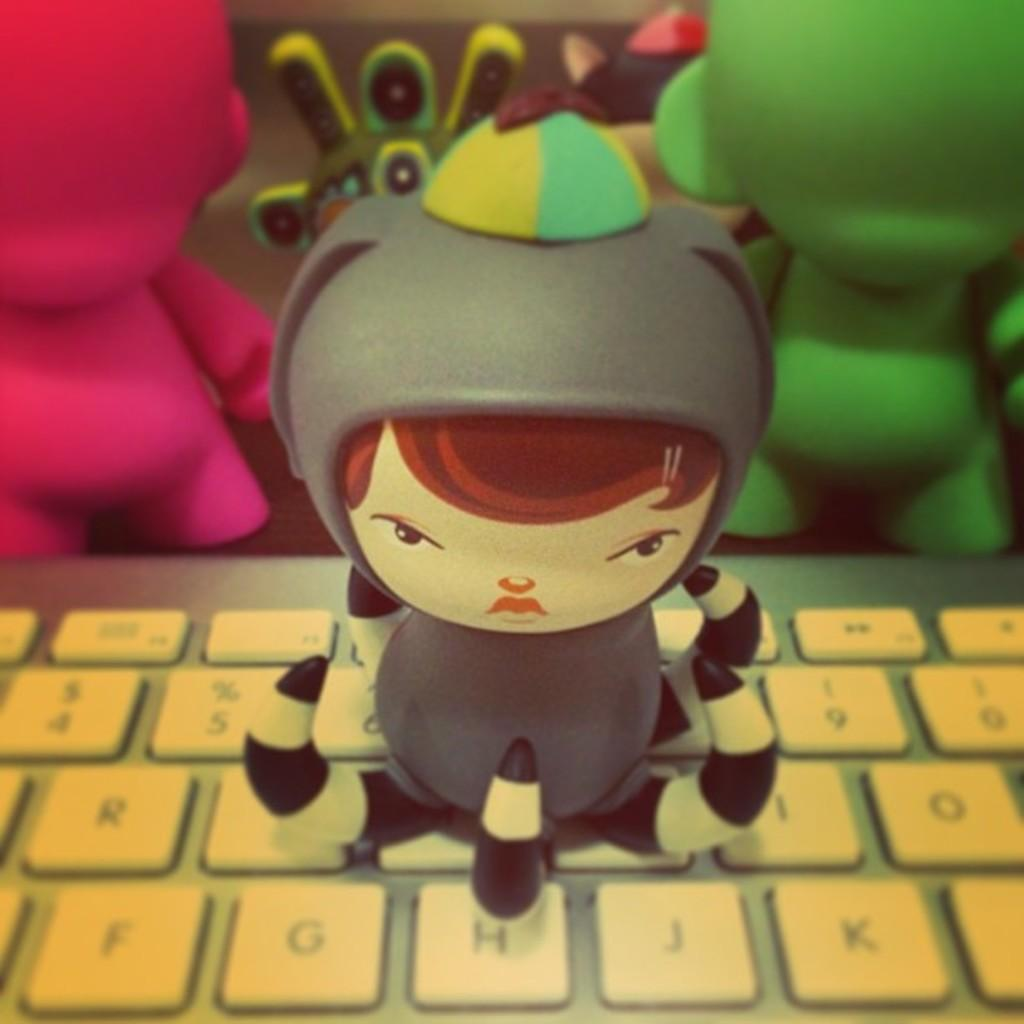What is placed on the keyboard in the image? There is a toy on a keyboard in the image. Can you describe the toys visible in the background of the image? Unfortunately, the provided facts do not give any details about the toys in the background. However, we can confirm that there are toys visible in the background. What type of glass is being used to play the airplane in the image? There is no glass or airplane present in the image. The image features a toy on a keyboard and toys visible in the background. 